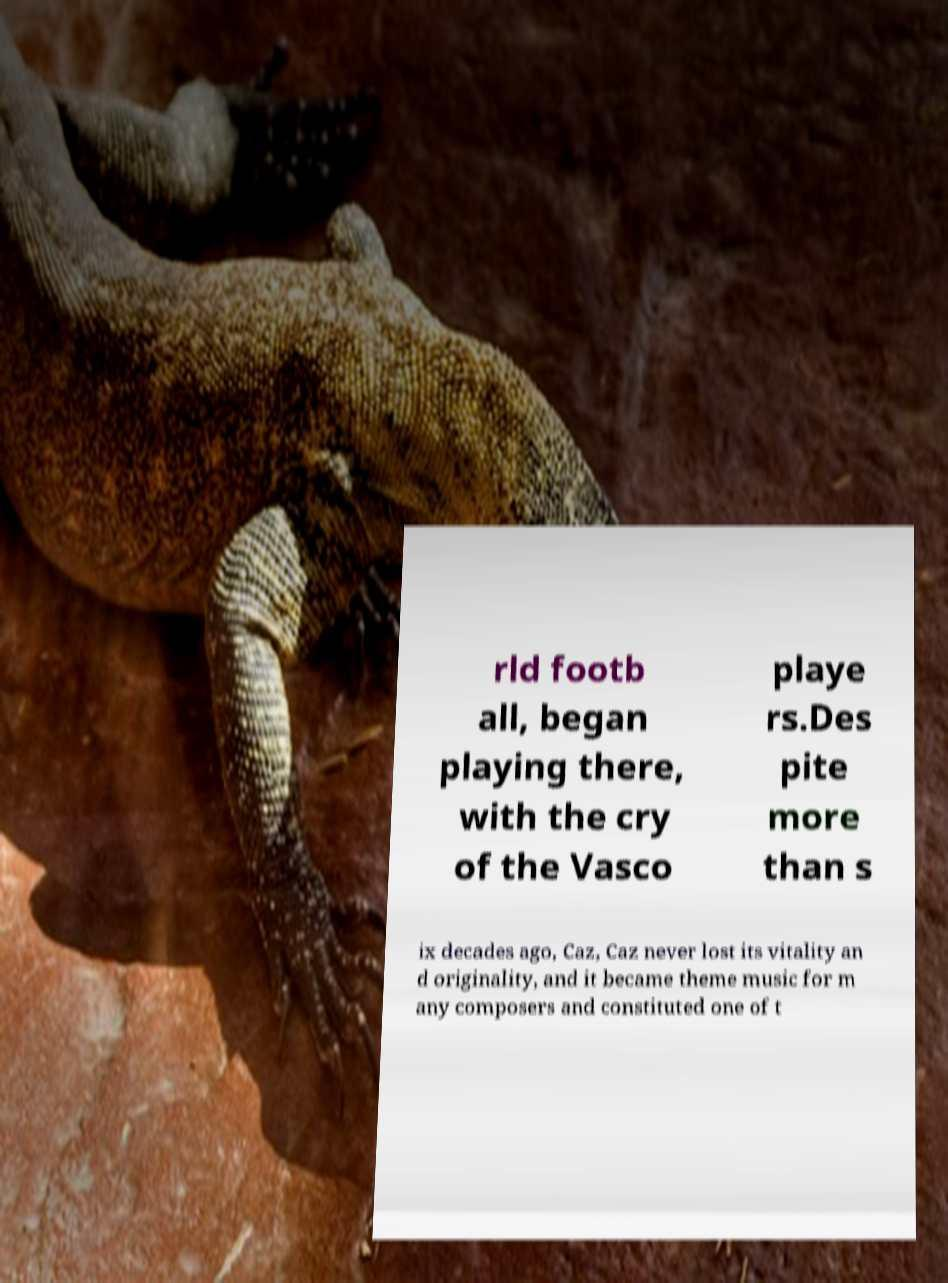What messages or text are displayed in this image? I need them in a readable, typed format. rld footb all, began playing there, with the cry of the Vasco playe rs.Des pite more than s ix decades ago, Caz, Caz never lost its vitality an d originality, and it became theme music for m any composers and constituted one of t 